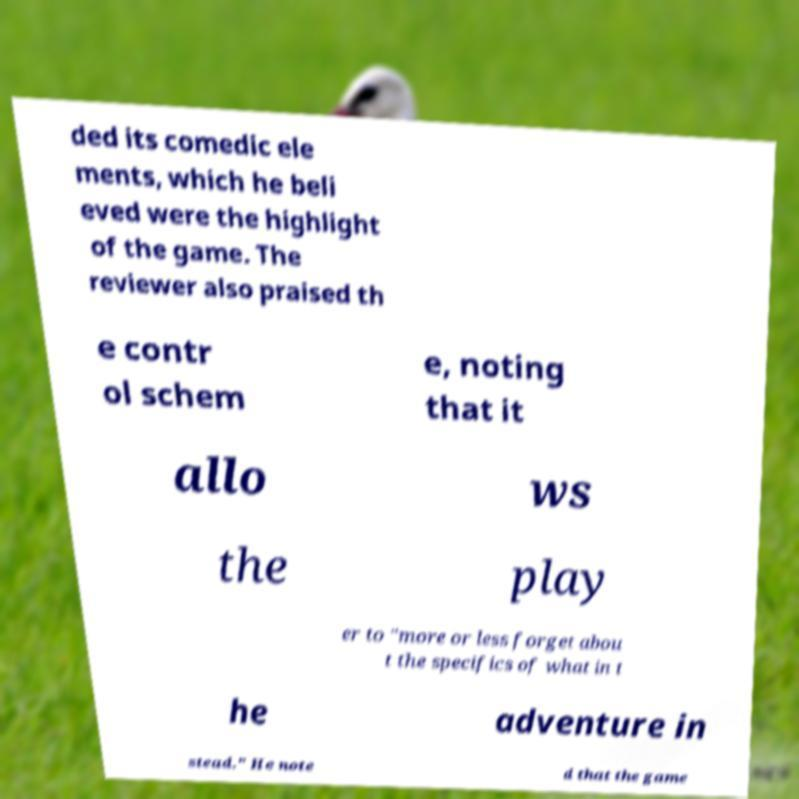I need the written content from this picture converted into text. Can you do that? ded its comedic ele ments, which he beli eved were the highlight of the game. The reviewer also praised th e contr ol schem e, noting that it allo ws the play er to "more or less forget abou t the specifics of what in t he adventure in stead." He note d that the game 